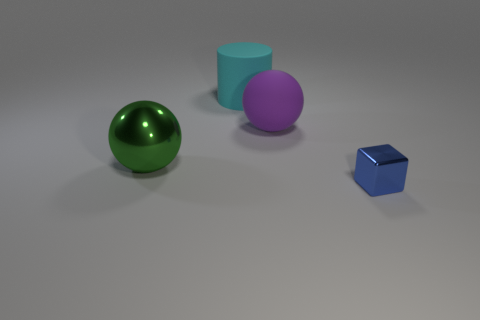There is a thing that is in front of the large green thing; what is its shape?
Your response must be concise. Cube. What number of things are both to the left of the big matte sphere and in front of the big cyan rubber cylinder?
Your answer should be compact. 1. Are there any cubes made of the same material as the green ball?
Provide a short and direct response. Yes. What number of cubes are either large gray shiny objects or blue objects?
Offer a very short reply. 1. How big is the blue metal cube?
Ensure brevity in your answer.  Small. There is a cylinder; how many balls are right of it?
Keep it short and to the point. 1. There is a ball to the right of the metallic thing that is on the left side of the blue cube; how big is it?
Your answer should be compact. Large. Do the rubber object on the right side of the cyan matte object and the metal object behind the tiny shiny cube have the same shape?
Your answer should be compact. Yes. There is a metallic object behind the metallic object to the right of the big cyan matte cylinder; what is its shape?
Your answer should be very brief. Sphere. There is a thing that is both in front of the cyan cylinder and behind the big green metal ball; what size is it?
Offer a terse response. Large. 